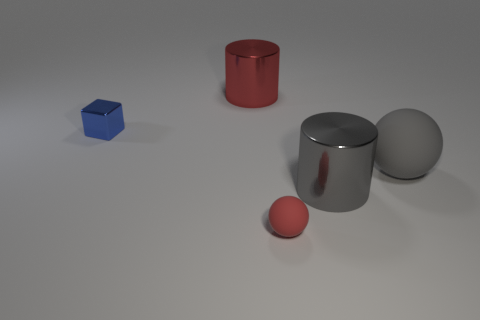The metal object that is the same color as the small ball is what size?
Your response must be concise. Large. How many things are either large objects that are right of the red metal cylinder or red objects that are in front of the large gray ball?
Your answer should be very brief. 3. The rubber sphere left of the metallic cylinder that is in front of the tiny metal cube is what color?
Your answer should be compact. Red. There is another ball that is the same material as the big gray sphere; what color is it?
Offer a terse response. Red. How many metal cylinders have the same color as the small matte ball?
Offer a very short reply. 1. How many objects are purple rubber cubes or small blocks?
Make the answer very short. 1. What is the shape of the gray rubber thing that is the same size as the red metallic thing?
Your answer should be compact. Sphere. What number of things are behind the large gray metal thing and in front of the large red thing?
Your answer should be very brief. 2. What is the material of the big cylinder behind the tiny blue metallic thing?
Offer a very short reply. Metal. There is a gray cylinder that is made of the same material as the blue thing; what is its size?
Make the answer very short. Large. 